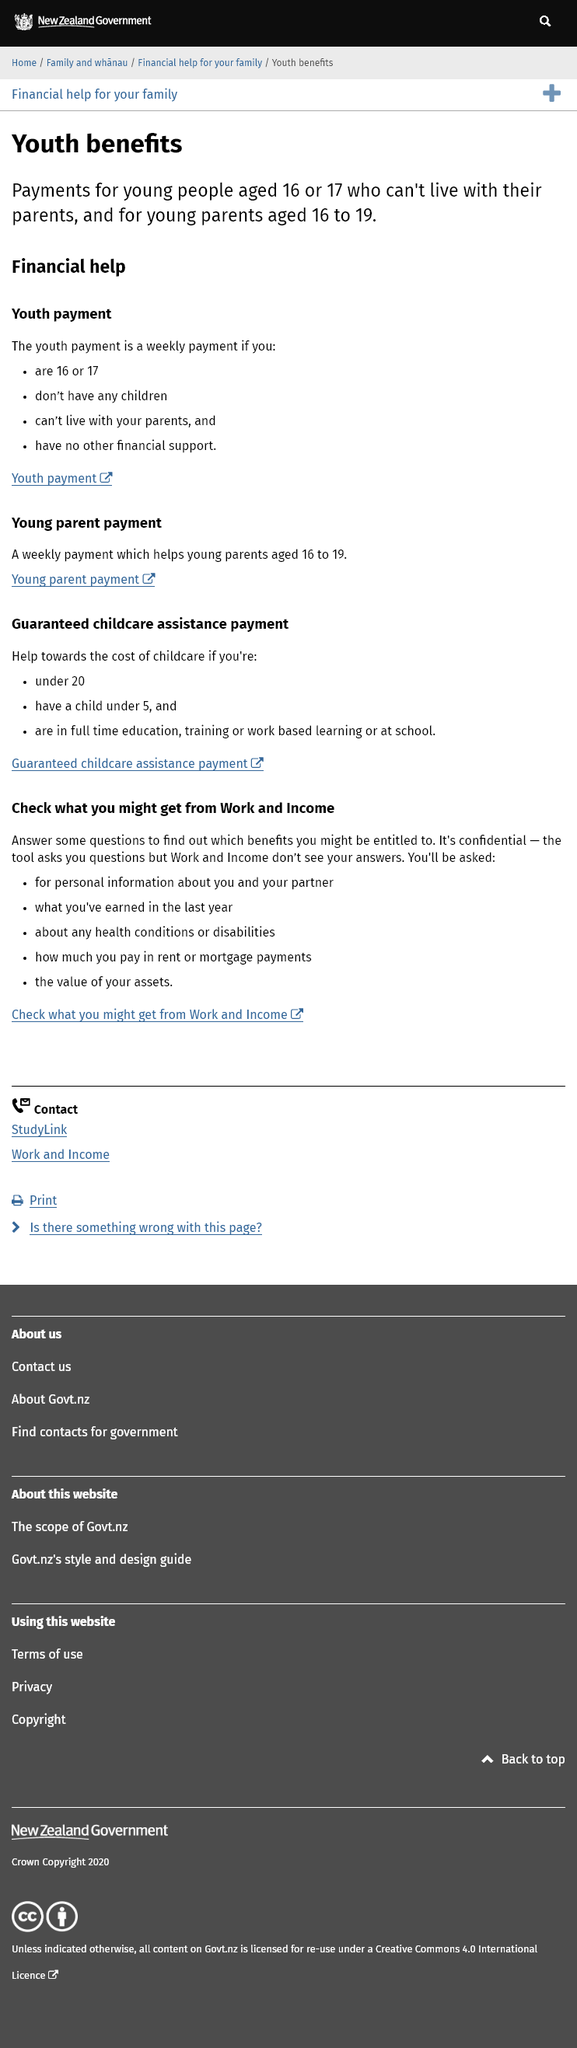Draw attention to some important aspects in this diagram. The young parent payment is available for young people aged 16 to 19 who are parents or expecting parents. The youth allowance is paid weekly. The youth payment is designed to assist individuals who are unable to live with their parents due to a lack of financial support. It does not provide assistance for those who are living with their parents. 